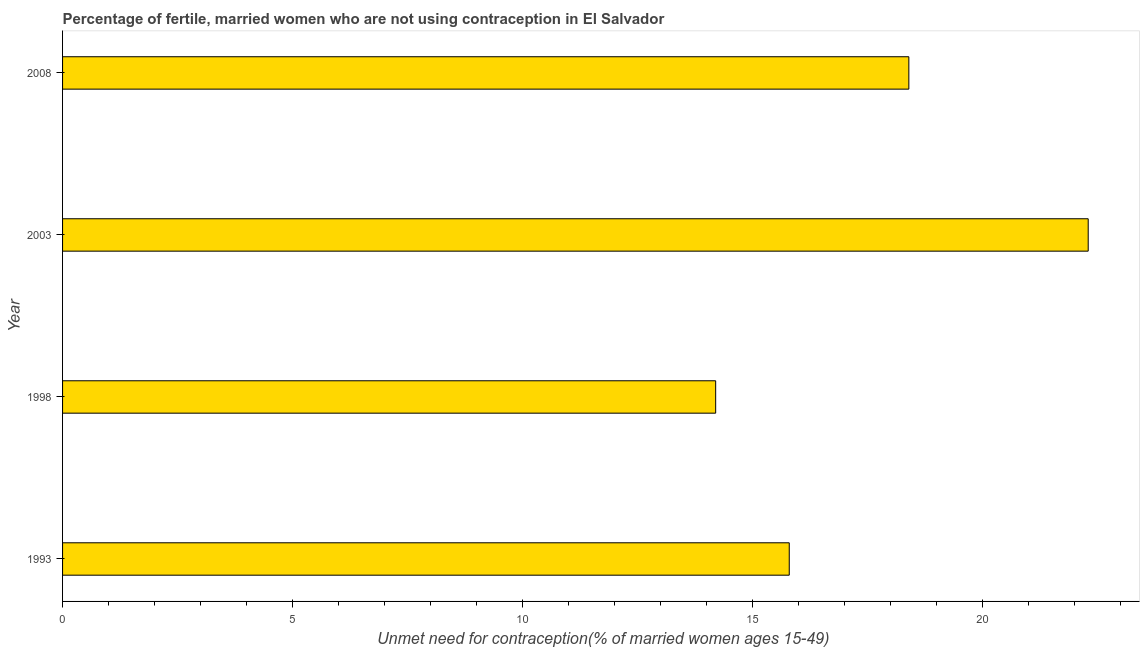Does the graph contain any zero values?
Ensure brevity in your answer.  No. Does the graph contain grids?
Your answer should be very brief. No. What is the title of the graph?
Keep it short and to the point. Percentage of fertile, married women who are not using contraception in El Salvador. What is the label or title of the X-axis?
Give a very brief answer.  Unmet need for contraception(% of married women ages 15-49). What is the label or title of the Y-axis?
Provide a succinct answer. Year. What is the number of married women who are not using contraception in 2003?
Your response must be concise. 22.3. Across all years, what is the maximum number of married women who are not using contraception?
Ensure brevity in your answer.  22.3. In which year was the number of married women who are not using contraception maximum?
Ensure brevity in your answer.  2003. In which year was the number of married women who are not using contraception minimum?
Provide a short and direct response. 1998. What is the sum of the number of married women who are not using contraception?
Offer a terse response. 70.7. What is the average number of married women who are not using contraception per year?
Ensure brevity in your answer.  17.68. What is the median number of married women who are not using contraception?
Your response must be concise. 17.1. In how many years, is the number of married women who are not using contraception greater than 10 %?
Offer a very short reply. 4. Do a majority of the years between 1998 and 1993 (inclusive) have number of married women who are not using contraception greater than 3 %?
Your answer should be very brief. No. What is the ratio of the number of married women who are not using contraception in 1993 to that in 2008?
Ensure brevity in your answer.  0.86. What is the difference between the highest and the second highest number of married women who are not using contraception?
Ensure brevity in your answer.  3.9. In how many years, is the number of married women who are not using contraception greater than the average number of married women who are not using contraception taken over all years?
Offer a very short reply. 2. Are all the bars in the graph horizontal?
Make the answer very short. Yes. How many years are there in the graph?
Ensure brevity in your answer.  4. What is the  Unmet need for contraception(% of married women ages 15-49) of 1998?
Provide a short and direct response. 14.2. What is the  Unmet need for contraception(% of married women ages 15-49) of 2003?
Provide a succinct answer. 22.3. What is the difference between the  Unmet need for contraception(% of married women ages 15-49) in 1993 and 2008?
Offer a very short reply. -2.6. What is the difference between the  Unmet need for contraception(% of married women ages 15-49) in 1998 and 2003?
Ensure brevity in your answer.  -8.1. What is the ratio of the  Unmet need for contraception(% of married women ages 15-49) in 1993 to that in 1998?
Your answer should be compact. 1.11. What is the ratio of the  Unmet need for contraception(% of married women ages 15-49) in 1993 to that in 2003?
Offer a terse response. 0.71. What is the ratio of the  Unmet need for contraception(% of married women ages 15-49) in 1993 to that in 2008?
Ensure brevity in your answer.  0.86. What is the ratio of the  Unmet need for contraception(% of married women ages 15-49) in 1998 to that in 2003?
Provide a short and direct response. 0.64. What is the ratio of the  Unmet need for contraception(% of married women ages 15-49) in 1998 to that in 2008?
Your answer should be compact. 0.77. What is the ratio of the  Unmet need for contraception(% of married women ages 15-49) in 2003 to that in 2008?
Provide a succinct answer. 1.21. 